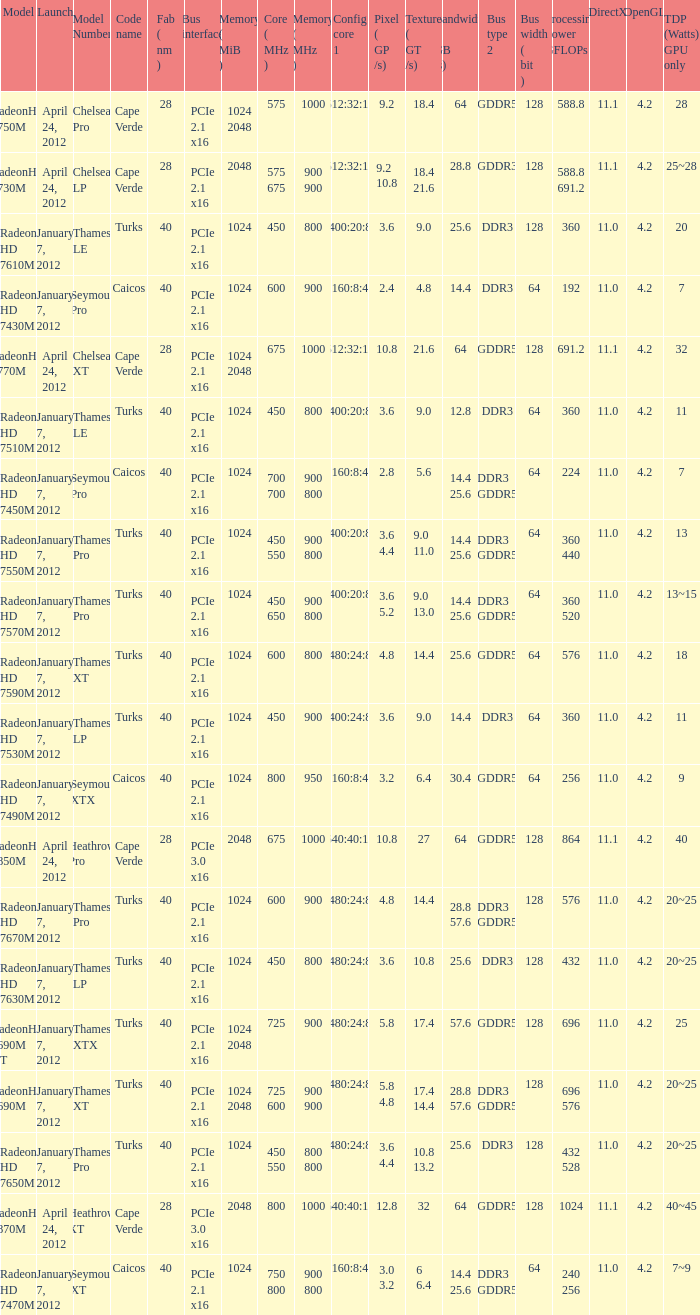How many texture (gt/s) the card has if the tdp (watts) GPU only is 18? 1.0. 